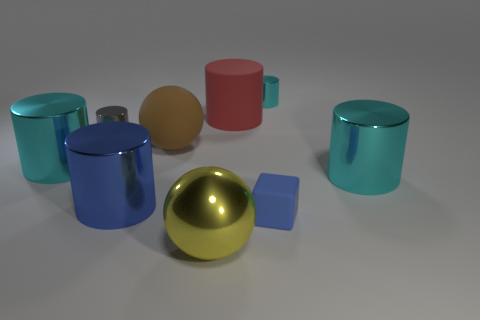How many matte things are large yellow spheres or big spheres?
Your answer should be very brief. 1. Is the blue cylinder the same size as the yellow thing?
Keep it short and to the point. Yes. Is the number of large brown things that are behind the tiny gray metallic cylinder less than the number of big yellow metal objects that are behind the small rubber block?
Your answer should be very brief. No. Are there any other things that have the same size as the yellow thing?
Your answer should be very brief. Yes. The gray cylinder is what size?
Offer a very short reply. Small. What number of small things are either gray metal cylinders or green things?
Your answer should be compact. 1. There is a yellow thing; does it have the same size as the cyan metallic object that is behind the red matte object?
Keep it short and to the point. No. Is there anything else that is the same shape as the yellow thing?
Provide a short and direct response. Yes. What number of small blue rubber balls are there?
Your answer should be very brief. 0. What number of green objects are either big metallic spheres or rubber things?
Provide a short and direct response. 0. 